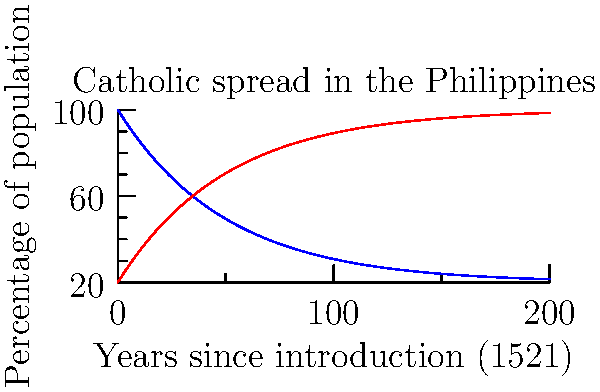Based on the graph showing the spread of Catholicism in the Philippines since its introduction in 1521, approximately how many years did it take for Catholics to become the majority (over 50%) of the population? To find when Catholics became the majority, we need to follow these steps:

1. Understand the graph: The blue line represents non-Catholics, and the red line represents Catholics.
2. Identify the crossing point: Where the red line crosses above the blue line, Catholics become the majority.
3. Find the x-coordinate of the crossing point: This represents the number of years since 1521.
4. Estimate the value: The lines appear to cross at around 35-40 years on the x-axis.
5. Calculate the year: 1521 + 35 to 40 years ≈ 1556 to 1561

Therefore, it took approximately 35-40 years for Catholics to become the majority in the Philippines after the introduction of Catholicism in 1521.
Answer: 35-40 years 